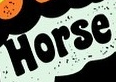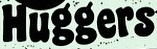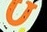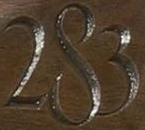Identify the words shown in these images in order, separated by a semicolon. Horse; Huggers; U; 283 